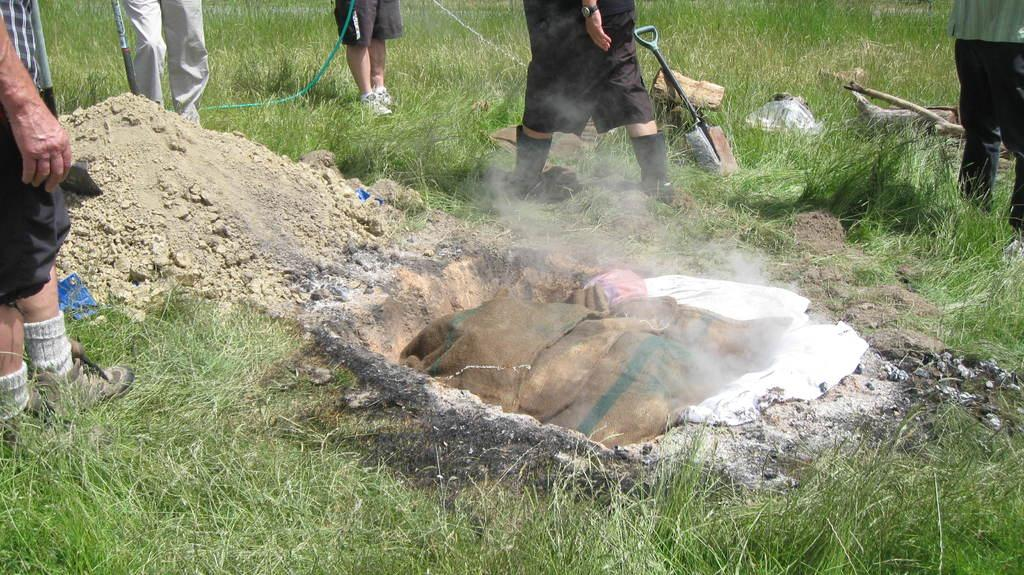What type of bags are visible in the image? There are gunny bags in the image. What is being stored in the gunny bags? The provided facts do not specify what is being stored in the gunny bags. What is the unusual location for the clothes in the image? The clothes are in a hole in the image. What can be seen in the background of the image? There are people, rocks, logs, ropes, and sand visible in the background of the image. What is the ground like in the image? The ground visible at the bottom of the image is not described in detail, but it is likely to be the same type of ground as the sand mentioned in the background. What type of cord is being used to mine the rocks in the image? There is no mention of mining or cords in the image. The image only shows gunny bags, clothes in a hole, people, rocks, logs, ropes, sand, and ground. 